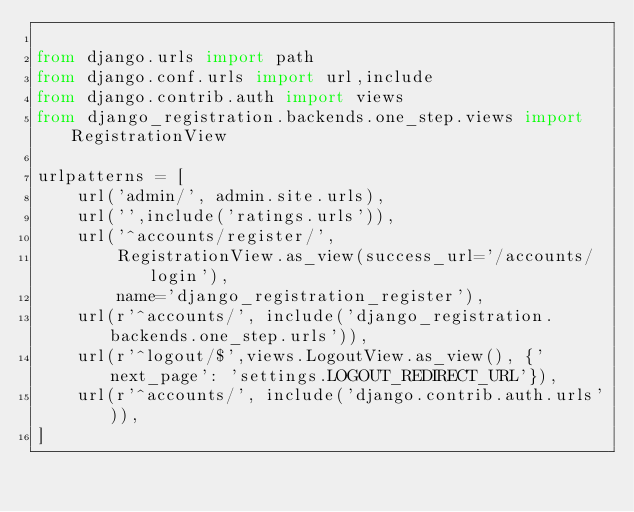<code> <loc_0><loc_0><loc_500><loc_500><_Python_>
from django.urls import path
from django.conf.urls import url,include
from django.contrib.auth import views
from django_registration.backends.one_step.views import RegistrationView

urlpatterns = [
    url('admin/', admin.site.urls),
    url('',include('ratings.urls')),
    url('^accounts/register/',
        RegistrationView.as_view(success_url='/accounts/login'),
        name='django_registration_register'),
    url(r'^accounts/', include('django_registration.backends.one_step.urls')),
    url(r'^logout/$',views.LogoutView.as_view(), {'next_page': 'settings.LOGOUT_REDIRECT_URL'}),
    url(r'^accounts/', include('django.contrib.auth.urls')),
]</code> 